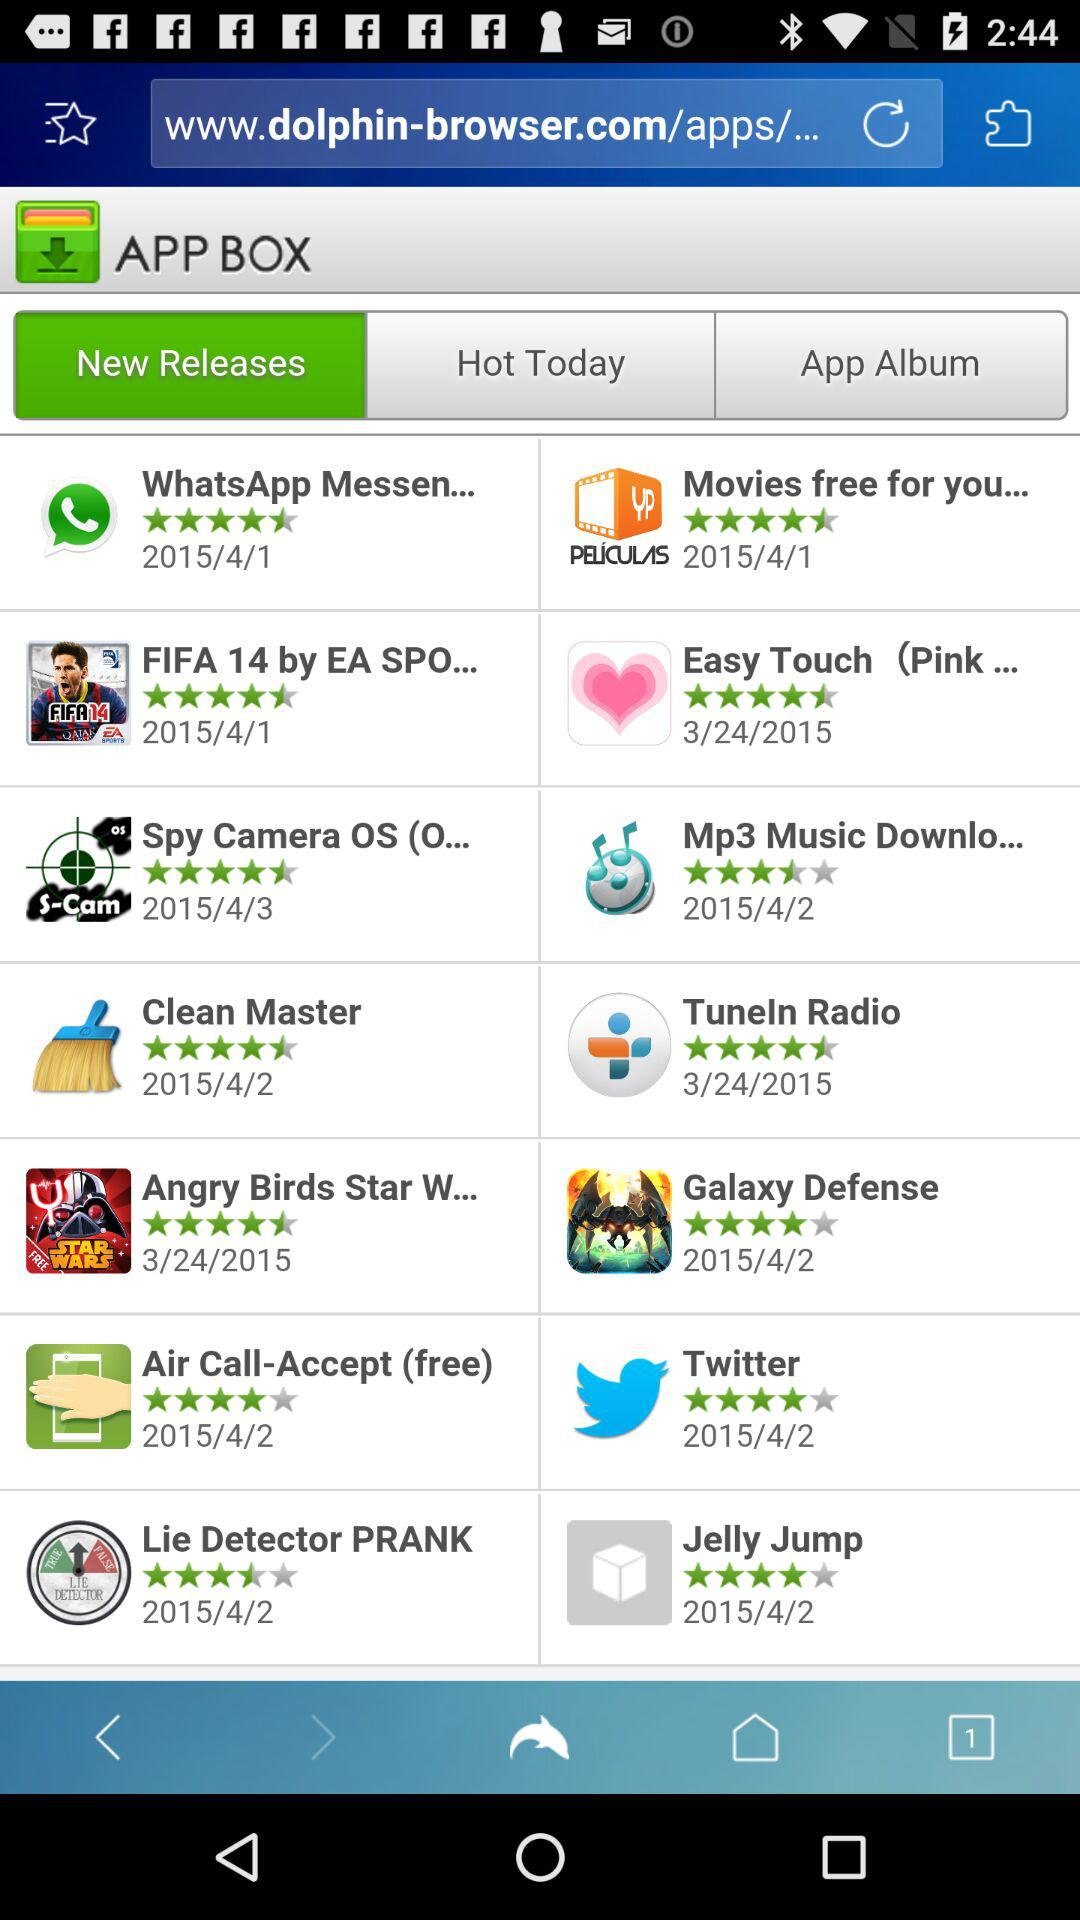What are the names of the newly released applications? The names are "WhatsApp Messen...", "Movies free for you...", "FIFA 14 by EA SPO...", "Easy Touch (Pink...", "Spy Camera OS (O...", "Mp3 Music Downlo...", "Clean Master", "Tuneln Radio", "Angry Birds Star W...", "Galaxy Defense", "Air Call-Accept (free)", "Twitter", "Lie Detector PRANK" and "Jelly Jump". 